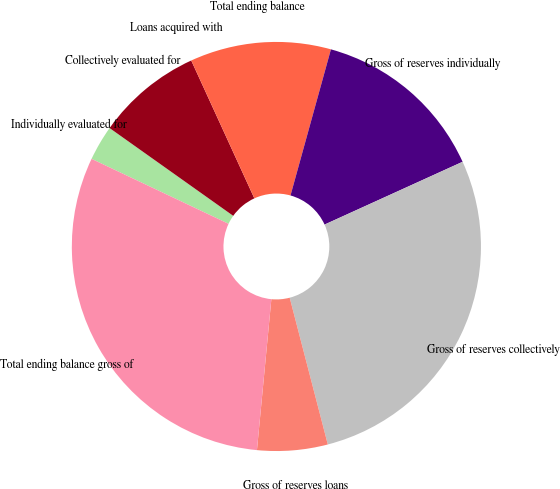Convert chart. <chart><loc_0><loc_0><loc_500><loc_500><pie_chart><fcel>Individually evaluated for<fcel>Collectively evaluated for<fcel>Loans acquired with<fcel>Total ending balance<fcel>Gross of reserves individually<fcel>Gross of reserves collectively<fcel>Gross of reserves loans<fcel>Total ending balance gross of<nl><fcel>2.78%<fcel>8.34%<fcel>0.0%<fcel>11.13%<fcel>13.91%<fcel>27.75%<fcel>5.56%<fcel>30.53%<nl></chart> 